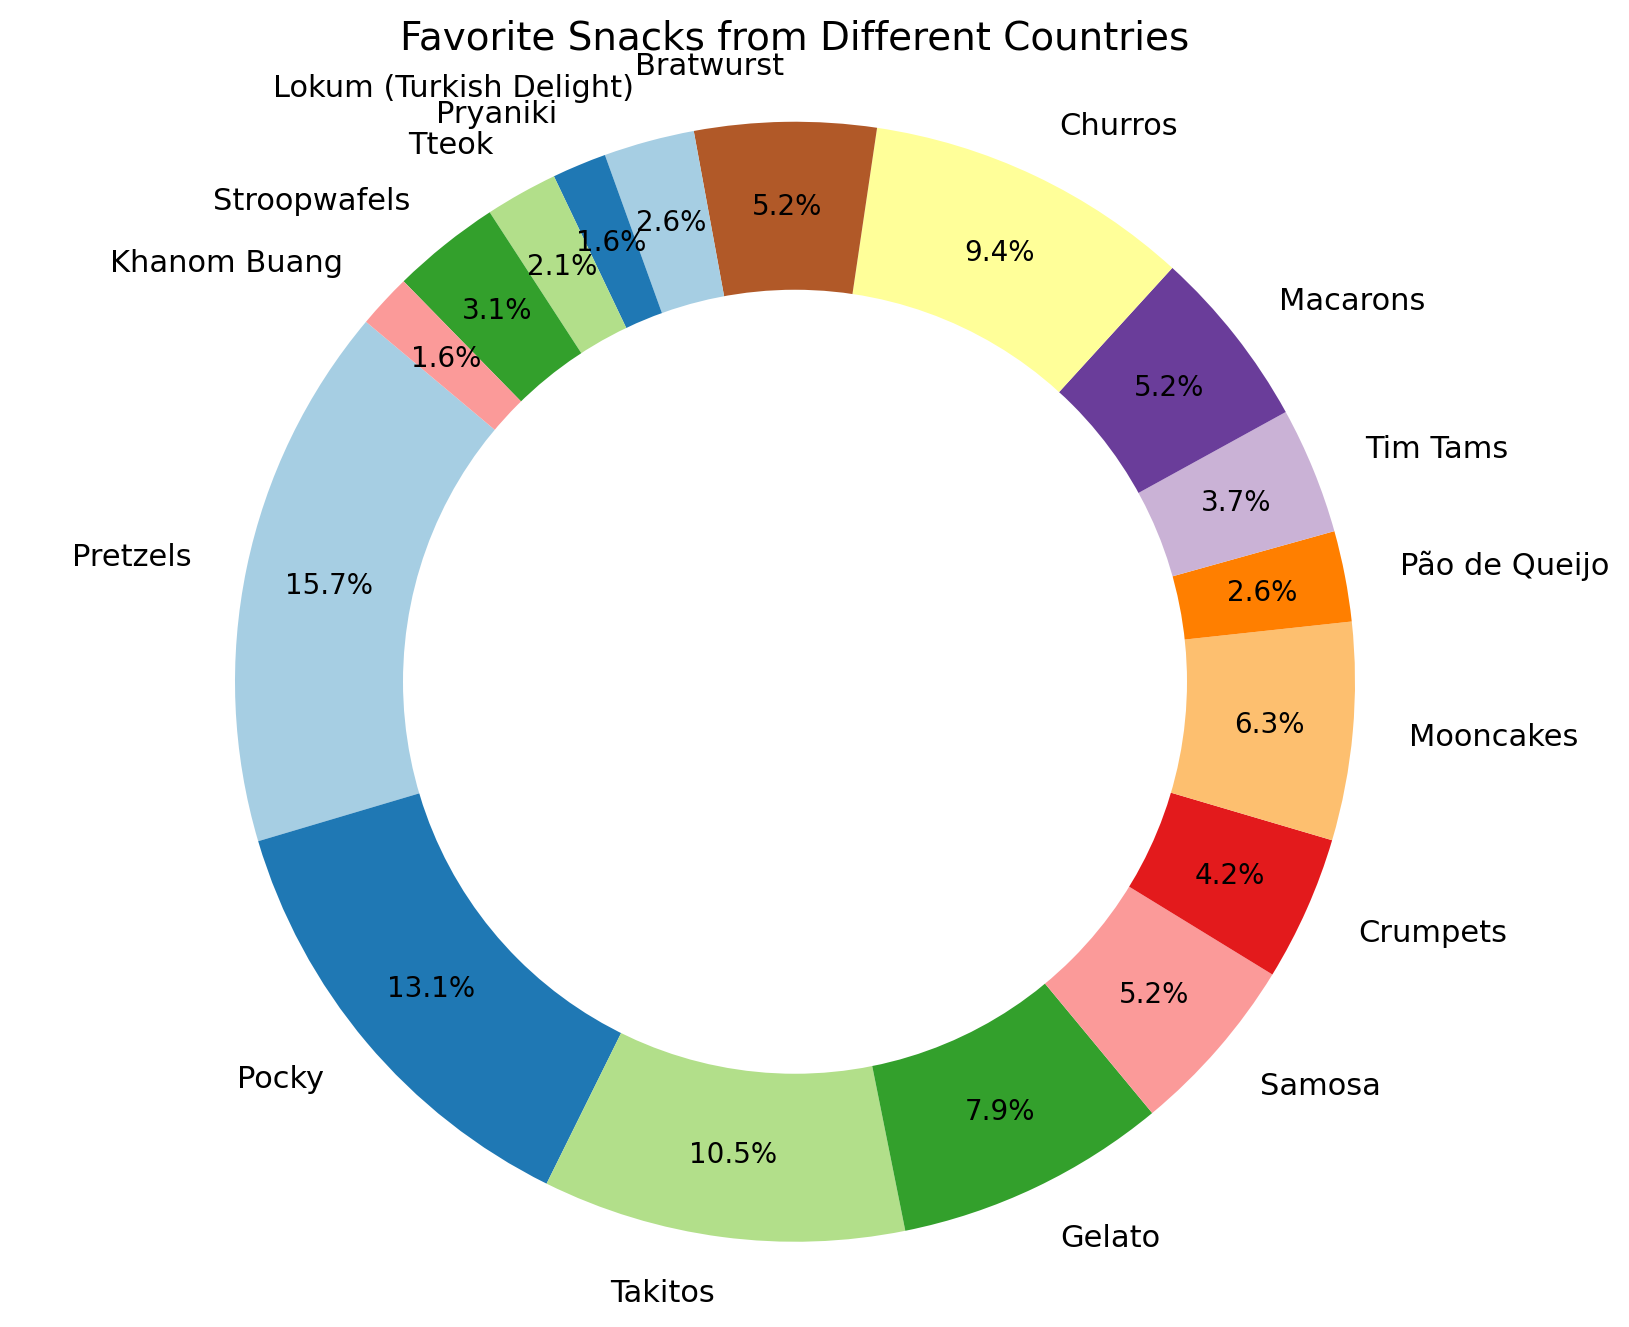What's the most favored snack among all countries? The ring chart shows the percentage values for each snack. The highest value corresponds to Pretzels from the USA, which has 30%.
Answer: Pretzels What's the sum of the popularity percentages of Pocky, Takitos and Gelato? Pocky (25%) + Takitos (20%) + Gelato (15%) = 25 + 20 + 15 = 60
Answer: 60 Are there any snacks with the same popularity percentage? If so, which ones? The chart shows that Samosa, Macarons, and Bratwurst each have 10% popularity.
Answer: Samosa, Macarons, Bratwurst Which snack is more popular, Pão de Queijo or Tteok? The chart shows Pão de Queijo has 5% popularity and Tteok has 4% popularity.
Answer: Pão de Queijo What is the difference in popularity between the most and least favored snacks? The most favored snack, Pretzels, has 30% popularity. The least favored snacks, Pryaniki and Khanom Buang, have 3% popularity each. The difference is 30 - 3 = 27.
Answer: 27 What's the average popularity of Crumpets, Mooncakes, and Tim Tams combined? Crumpets (8%) + Mooncakes (12%) + Tim Tams (7%) = 8 + 12 + 7 = 27. Average = 27/3 = 9.
Answer: 9 Which country’s snack has the lowest popularity and what is the snack? The lowest popularity percentages (3%) belong to Khanom Buang from Thailand and Pryaniki from Russia.
Answer: Thailand and Russia If you combine the popularity percentages of Italian and Spanish snacks, how much does it total? Gelato (15%) + Churros (18%) = 15 + 18 = 33
Answer: 33 Is the popularity of Mooncakes higher or lower than Crumpets? Mooncakes have 12% popularity, whereas Crumpets have 8%. Hence, Mooncakes are more popular.
Answer: Higher What’s the combined popularity percentage of snacks from Brazil and Turkey? Pão de Queijo (5%) + Lokum (5%) = 5 + 5 = 10
Answer: 10 